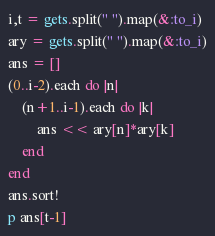<code> <loc_0><loc_0><loc_500><loc_500><_Ruby_>i,t = gets.split(" ").map(&:to_i)
ary = gets.split(" ").map(&:to_i)
ans = []
(0..i-2).each do |n|
    (n+1..i-1).each do |k|
        ans << ary[n]*ary[k]
    end
end
ans.sort!
p ans[t-1]</code> 